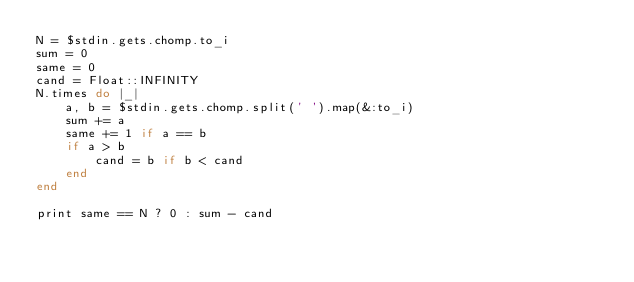<code> <loc_0><loc_0><loc_500><loc_500><_Ruby_>N = $stdin.gets.chomp.to_i
sum = 0
same = 0
cand = Float::INFINITY
N.times do |_|
    a, b = $stdin.gets.chomp.split(' ').map(&:to_i)
    sum += a
    same += 1 if a == b
    if a > b
        cand = b if b < cand
    end
end

print same == N ? 0 : sum - cand</code> 